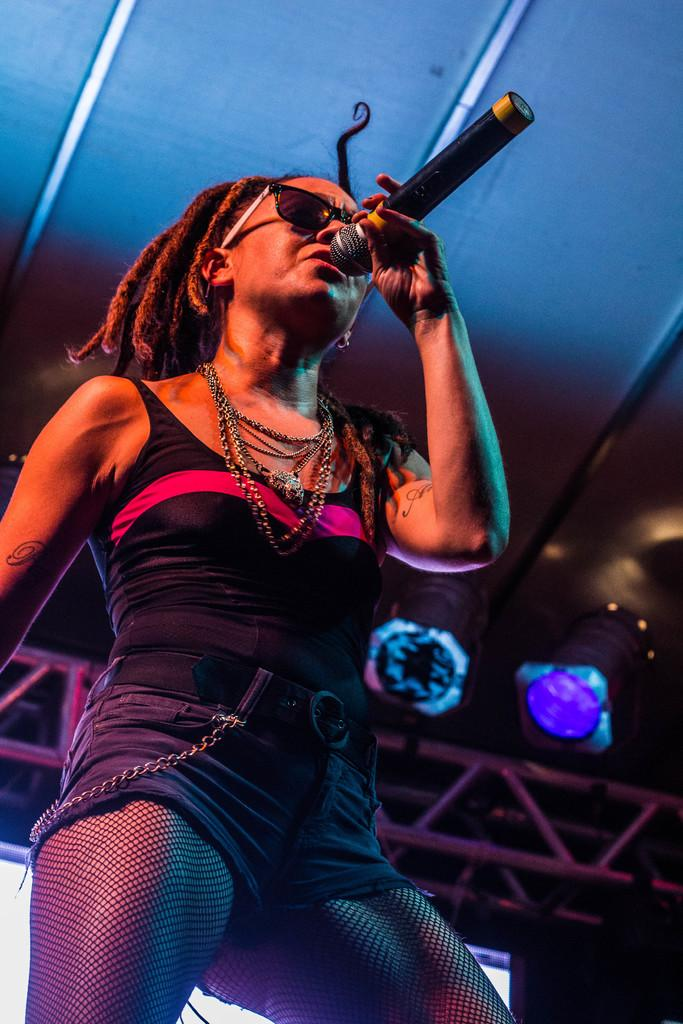Who is in the image? There is a person in the image. What is the person holding? The person is holding a microphone. What can be seen behind the person? There is a screen behind the person. What materials are visible at the top of the image? Metal rods and lights are present at the top of the image. What type of snow can be seen falling in the image? There is no snow present in the image. How does the person say good-bye to the audience in the image? The image does not show the person saying good-bye to the audience, as it only shows the person holding a microphone and standing in front of a screen. 